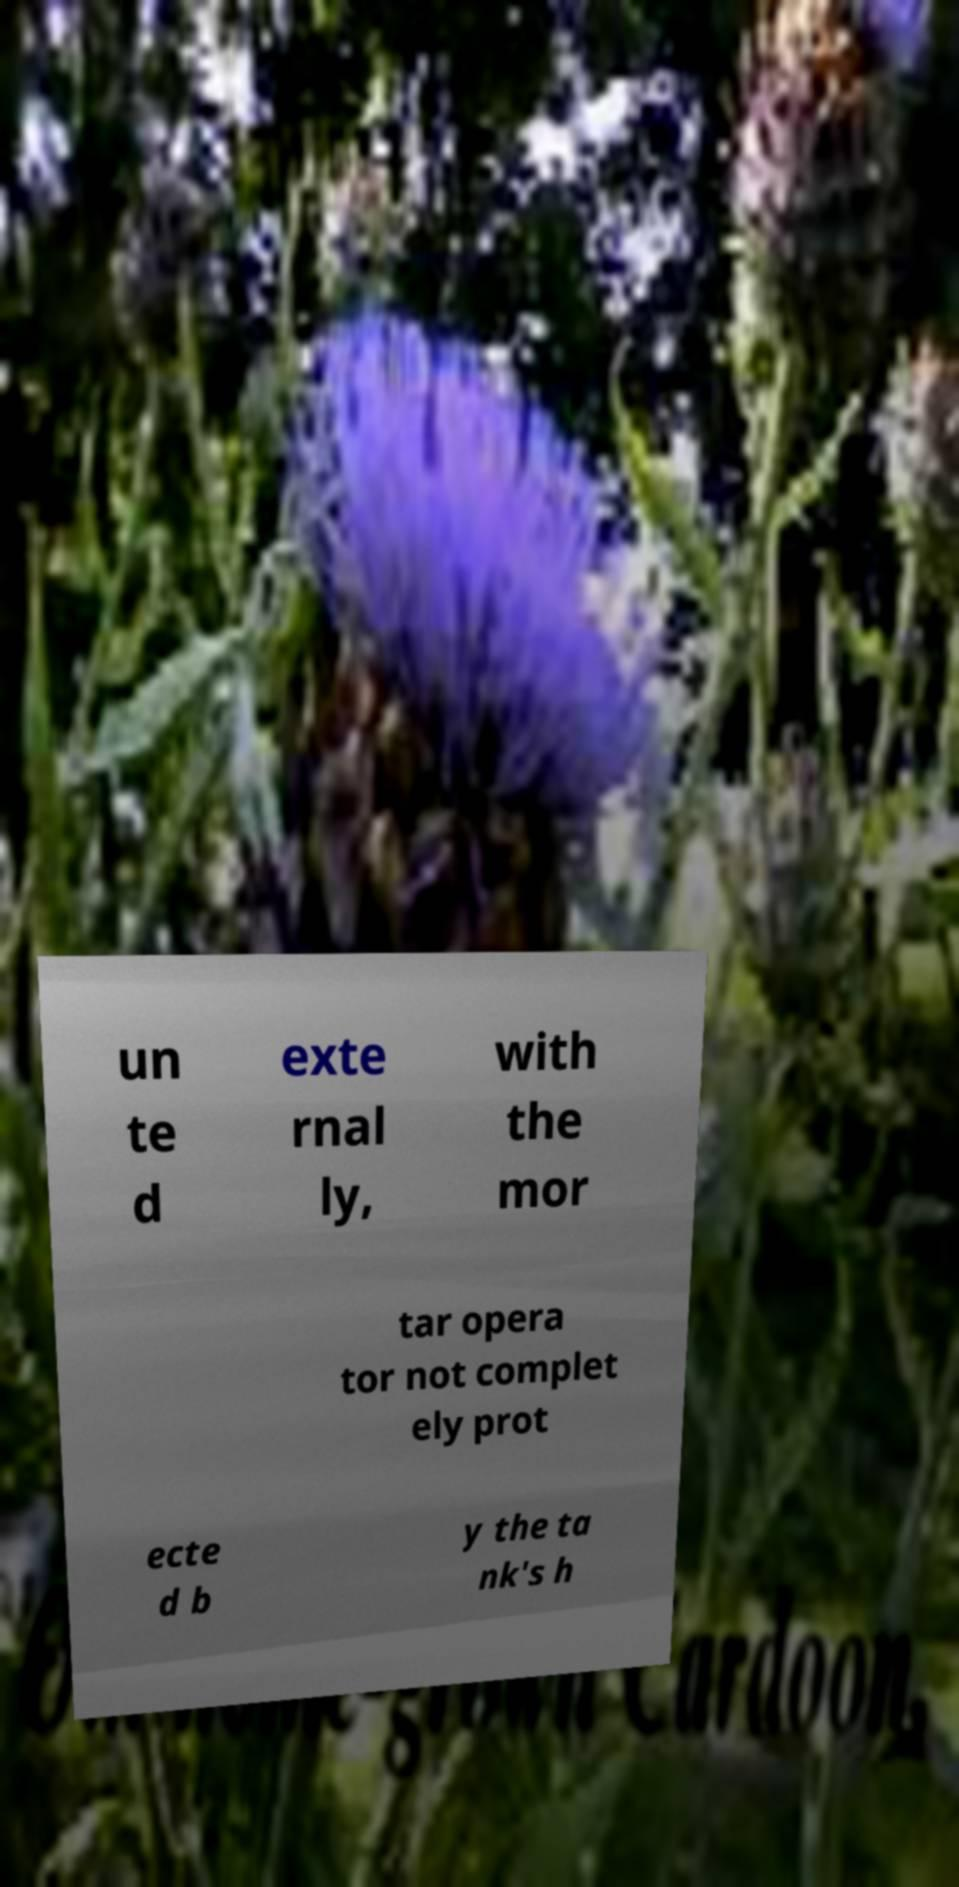I need the written content from this picture converted into text. Can you do that? un te d exte rnal ly, with the mor tar opera tor not complet ely prot ecte d b y the ta nk's h 